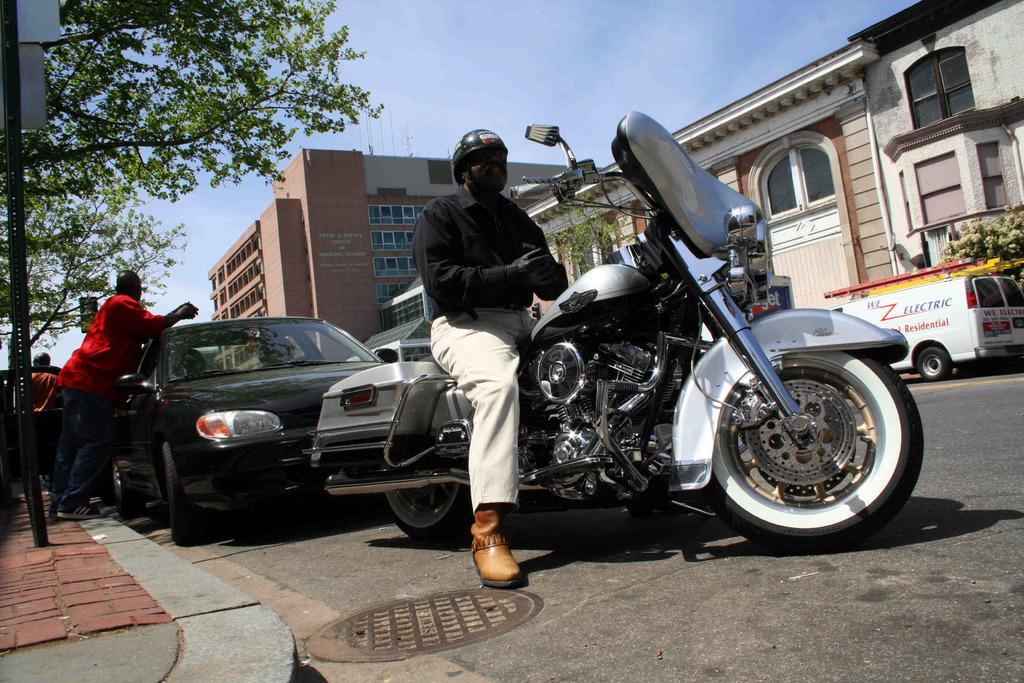Please provide a concise description of this image. This man is sitting on a motorbike and wore helmet. These are buildings with windows. Vehicles on road. Beside this vehicle a person is standing. 